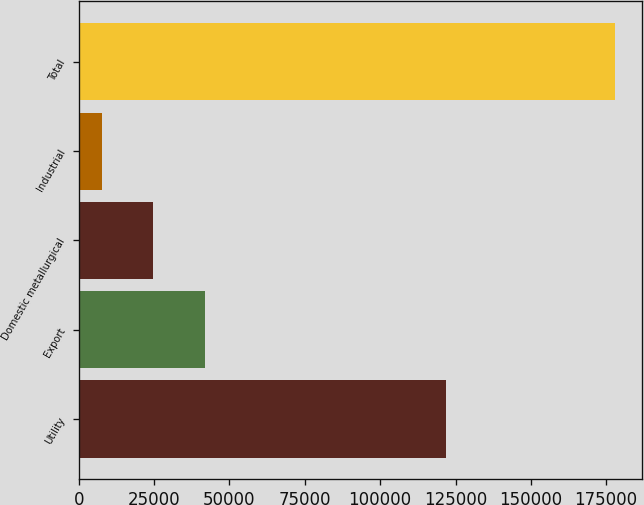<chart> <loc_0><loc_0><loc_500><loc_500><bar_chart><fcel>Utility<fcel>Export<fcel>Domestic metallurgical<fcel>Industrial<fcel>Total<nl><fcel>122004<fcel>41746.4<fcel>24729.7<fcel>7713<fcel>177880<nl></chart> 